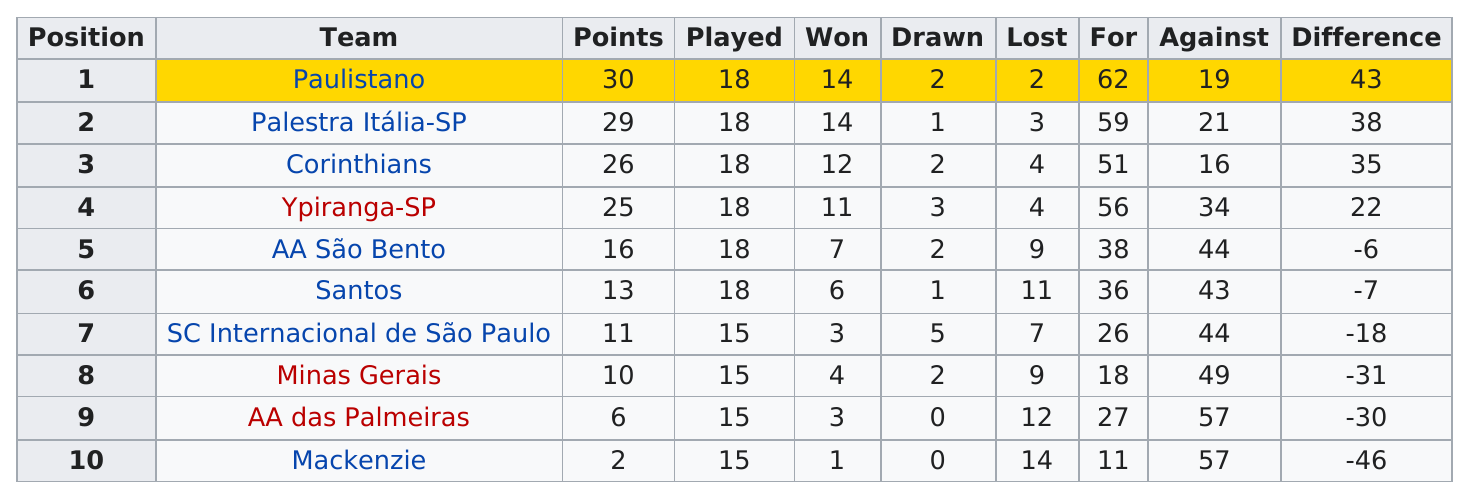Indicate a few pertinent items in this graphic. In 1919, the total number of teams that played Brazilian football was 10. Mackenzie scored the least amount of points. The Brazilian football team of 1919, led by President Manuel Joaquim de Macedo, won the least amount of points in their history. Mackenzie did not accumulate more than 5 points in any one point. The Paulistano team has a difference in points of 4 with the Corinthians. 